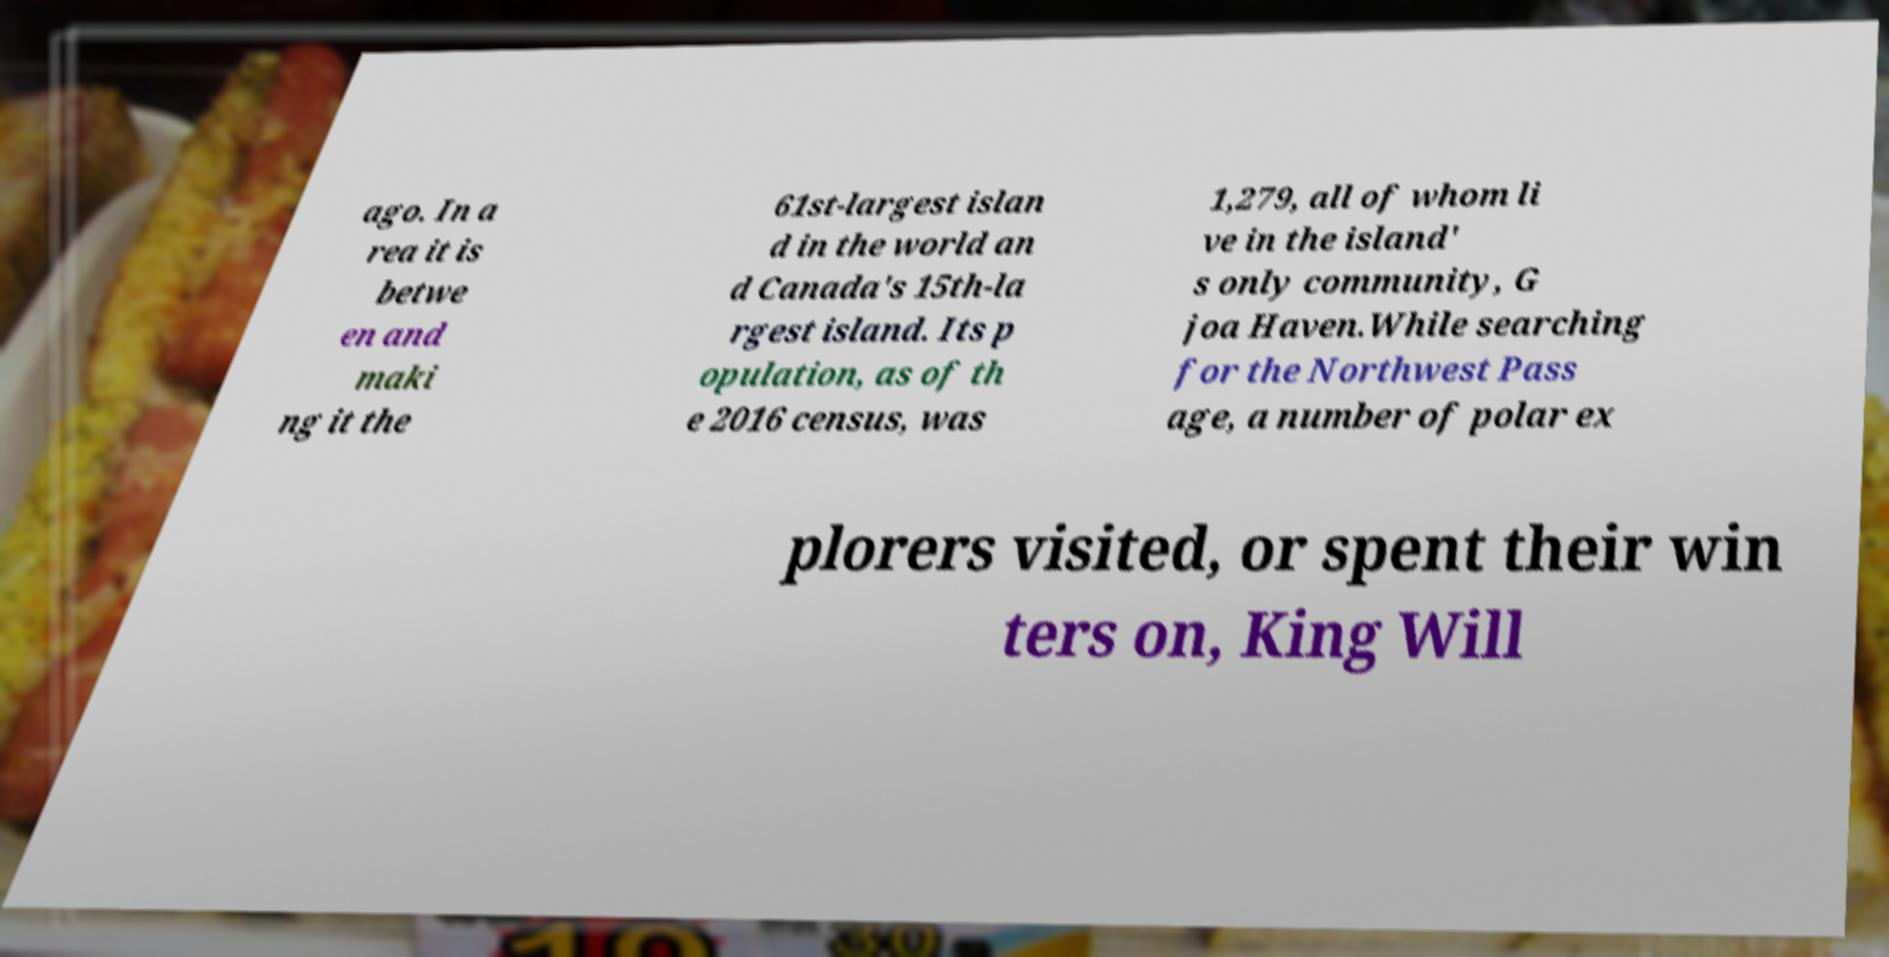Could you assist in decoding the text presented in this image and type it out clearly? ago. In a rea it is betwe en and maki ng it the 61st-largest islan d in the world an d Canada's 15th-la rgest island. Its p opulation, as of th e 2016 census, was 1,279, all of whom li ve in the island' s only community, G joa Haven.While searching for the Northwest Pass age, a number of polar ex plorers visited, or spent their win ters on, King Will 